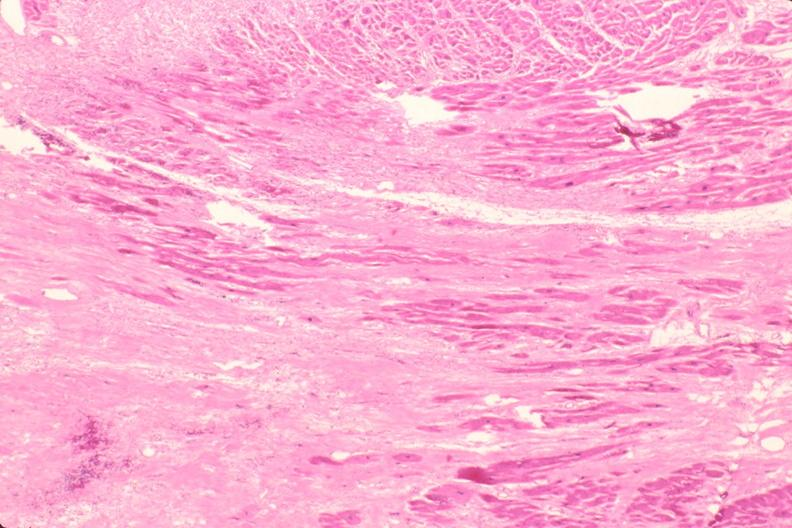does an opened peritoneal cavity cause by fibrous band strangulation show heart, fibrosis, chronic rheumatic heart disease?
Answer the question using a single word or phrase. No 